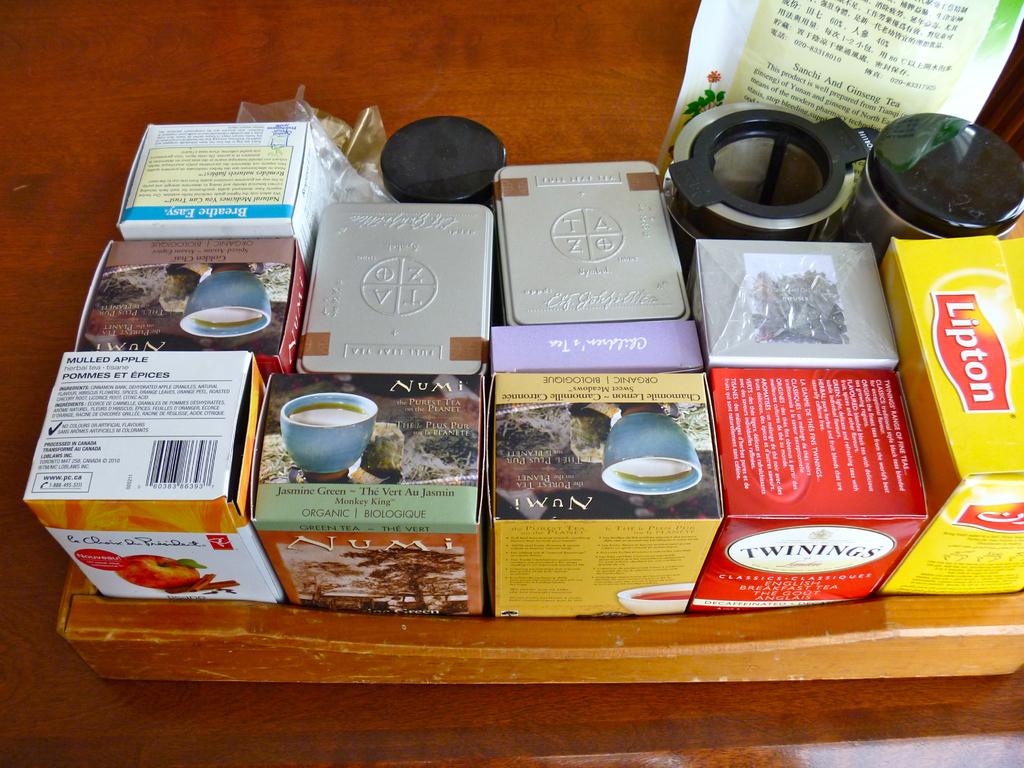Who makes the tea in the red box?
Make the answer very short. Twinings. Who makes the tea in the yellow box>?
Your response must be concise. Lipton. 